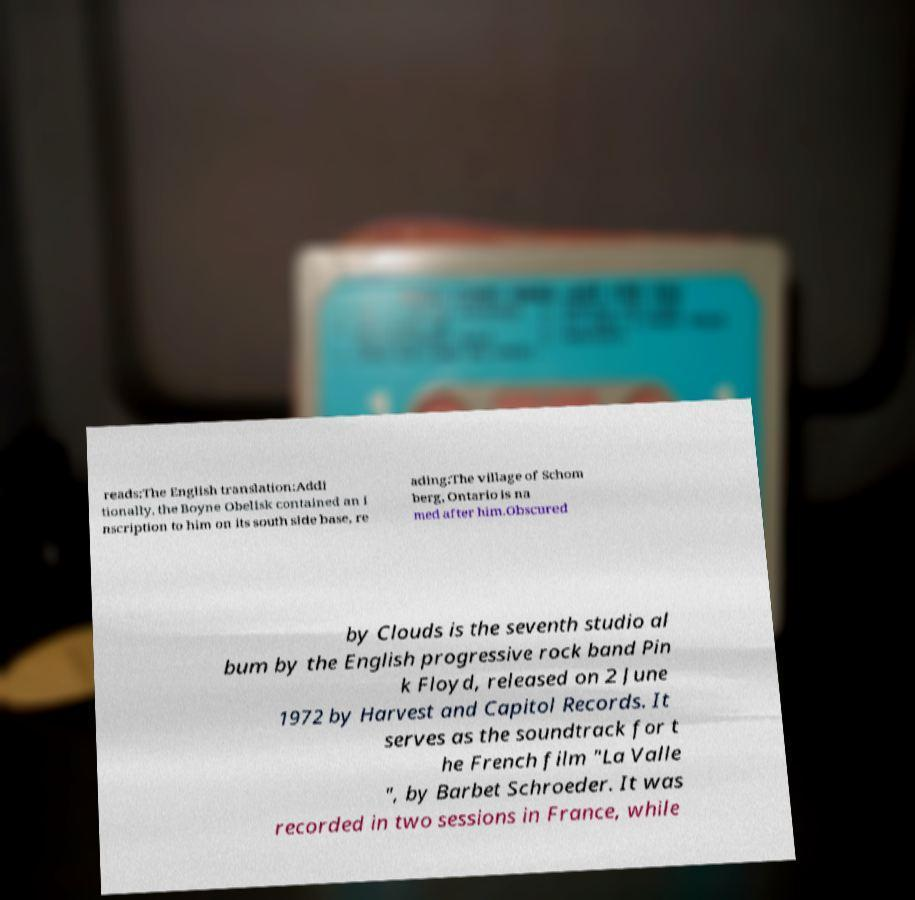Could you assist in decoding the text presented in this image and type it out clearly? reads:The English translation:Addi tionally, the Boyne Obelisk contained an i nscription to him on its south side base, re ading:The village of Schom berg, Ontario is na med after him.Obscured by Clouds is the seventh studio al bum by the English progressive rock band Pin k Floyd, released on 2 June 1972 by Harvest and Capitol Records. It serves as the soundtrack for t he French film "La Valle ", by Barbet Schroeder. It was recorded in two sessions in France, while 